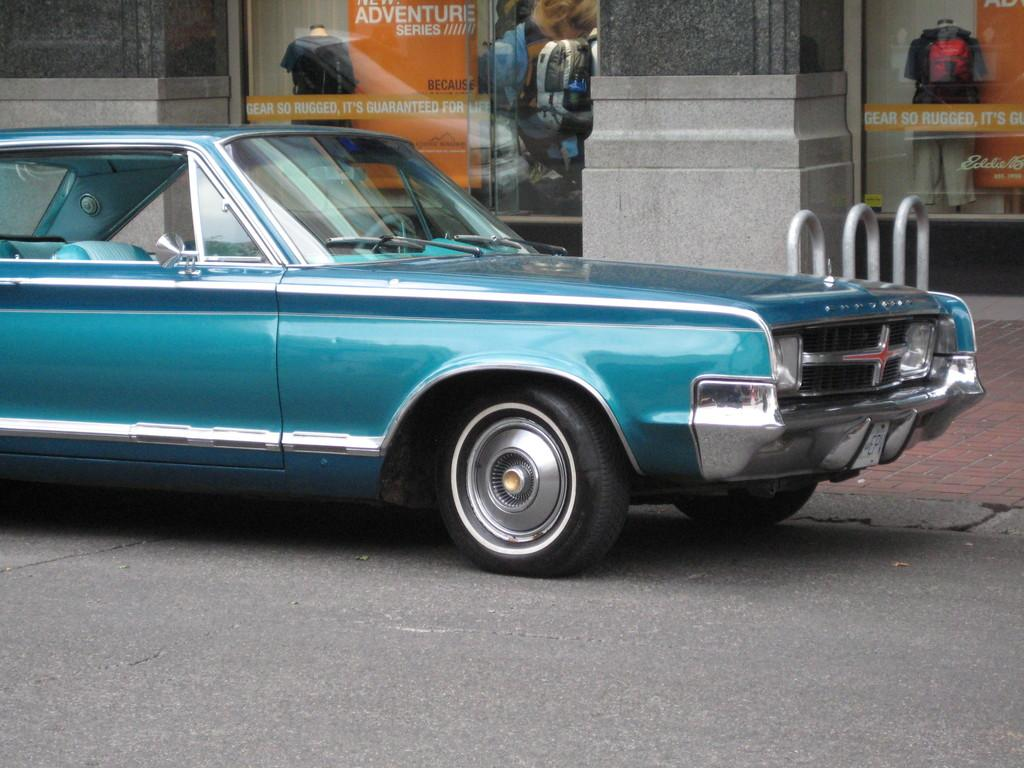What type of vehicle is on the road in the image? There is a motor vehicle on the road in the image. What else can be seen in the image besides the motor vehicle? There is a mannequin with a dress and an advertisement board in the image. What type of turkey is being advertised on the carpenter's jail in the image? There is no turkey, carpenter, or jail present in the image. 